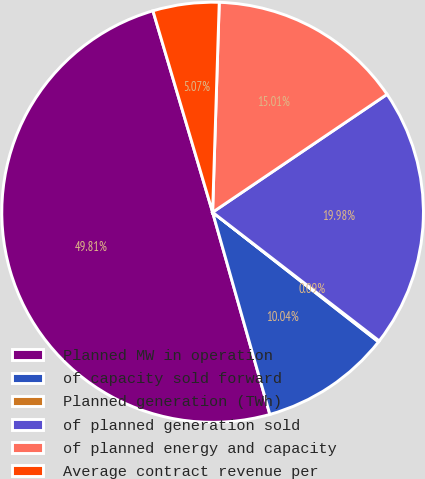<chart> <loc_0><loc_0><loc_500><loc_500><pie_chart><fcel>Planned MW in operation<fcel>of capacity sold forward<fcel>Planned generation (TWh)<fcel>of planned generation sold<fcel>of planned energy and capacity<fcel>Average contract revenue per<nl><fcel>49.81%<fcel>10.04%<fcel>0.09%<fcel>19.98%<fcel>15.01%<fcel>5.07%<nl></chart> 